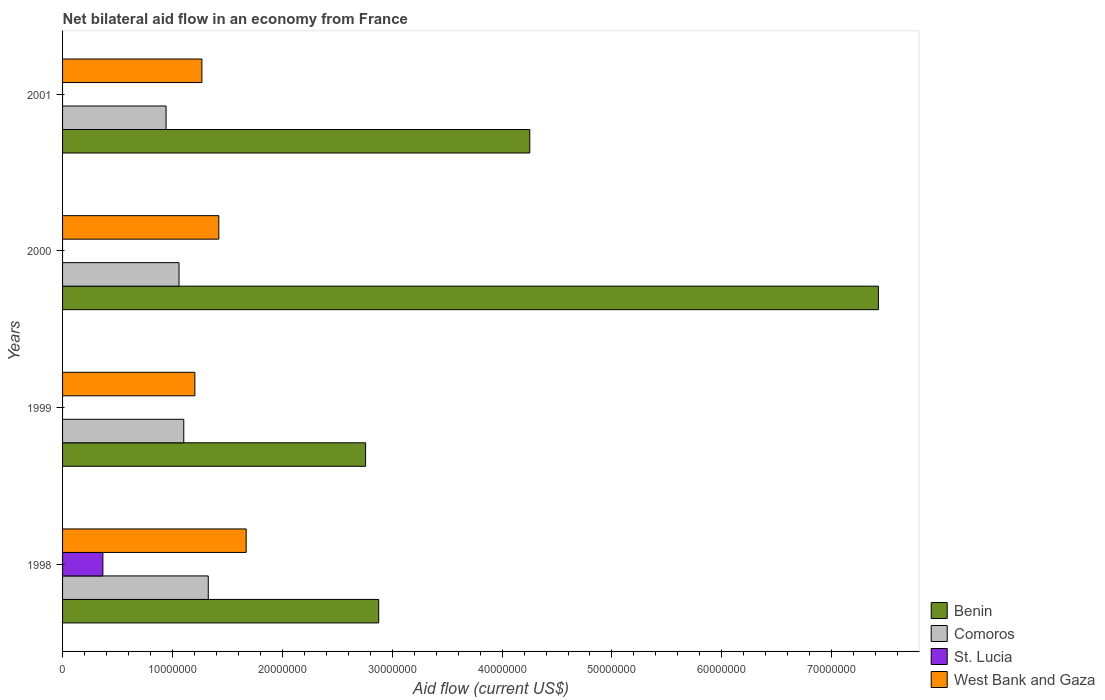How many groups of bars are there?
Your answer should be compact. 4. Are the number of bars on each tick of the Y-axis equal?
Give a very brief answer. No. How many bars are there on the 2nd tick from the top?
Keep it short and to the point. 3. In how many cases, is the number of bars for a given year not equal to the number of legend labels?
Ensure brevity in your answer.  3. What is the net bilateral aid flow in West Bank and Gaza in 2000?
Provide a succinct answer. 1.42e+07. Across all years, what is the maximum net bilateral aid flow in West Bank and Gaza?
Provide a short and direct response. 1.67e+07. Across all years, what is the minimum net bilateral aid flow in Comoros?
Your answer should be very brief. 9.42e+06. In which year was the net bilateral aid flow in Comoros maximum?
Make the answer very short. 1998. What is the total net bilateral aid flow in West Bank and Gaza in the graph?
Give a very brief answer. 5.56e+07. What is the difference between the net bilateral aid flow in West Bank and Gaza in 1999 and that in 2000?
Your response must be concise. -2.18e+06. What is the difference between the net bilateral aid flow in West Bank and Gaza in 1998 and the net bilateral aid flow in St. Lucia in 2001?
Keep it short and to the point. 1.67e+07. What is the average net bilateral aid flow in Comoros per year?
Keep it short and to the point. 1.11e+07. In the year 2000, what is the difference between the net bilateral aid flow in West Bank and Gaza and net bilateral aid flow in Benin?
Ensure brevity in your answer.  -6.00e+07. What is the ratio of the net bilateral aid flow in West Bank and Gaza in 1998 to that in 2000?
Offer a very short reply. 1.18. Is the difference between the net bilateral aid flow in West Bank and Gaza in 2000 and 2001 greater than the difference between the net bilateral aid flow in Benin in 2000 and 2001?
Your response must be concise. No. What is the difference between the highest and the second highest net bilateral aid flow in Comoros?
Ensure brevity in your answer.  2.23e+06. What is the difference between the highest and the lowest net bilateral aid flow in Benin?
Keep it short and to the point. 4.67e+07. In how many years, is the net bilateral aid flow in St. Lucia greater than the average net bilateral aid flow in St. Lucia taken over all years?
Make the answer very short. 1. Is it the case that in every year, the sum of the net bilateral aid flow in Benin and net bilateral aid flow in Comoros is greater than the sum of net bilateral aid flow in St. Lucia and net bilateral aid flow in West Bank and Gaza?
Offer a terse response. No. Is it the case that in every year, the sum of the net bilateral aid flow in West Bank and Gaza and net bilateral aid flow in Benin is greater than the net bilateral aid flow in St. Lucia?
Offer a terse response. Yes. How many bars are there?
Ensure brevity in your answer.  13. Are all the bars in the graph horizontal?
Your answer should be compact. Yes. How many legend labels are there?
Your answer should be very brief. 4. What is the title of the graph?
Provide a succinct answer. Net bilateral aid flow in an economy from France. What is the label or title of the X-axis?
Ensure brevity in your answer.  Aid flow (current US$). What is the Aid flow (current US$) of Benin in 1998?
Offer a terse response. 2.88e+07. What is the Aid flow (current US$) of Comoros in 1998?
Your answer should be compact. 1.33e+07. What is the Aid flow (current US$) in St. Lucia in 1998?
Your response must be concise. 3.67e+06. What is the Aid flow (current US$) of West Bank and Gaza in 1998?
Ensure brevity in your answer.  1.67e+07. What is the Aid flow (current US$) of Benin in 1999?
Give a very brief answer. 2.76e+07. What is the Aid flow (current US$) of Comoros in 1999?
Make the answer very short. 1.10e+07. What is the Aid flow (current US$) in St. Lucia in 1999?
Make the answer very short. 0. What is the Aid flow (current US$) in West Bank and Gaza in 1999?
Keep it short and to the point. 1.20e+07. What is the Aid flow (current US$) in Benin in 2000?
Give a very brief answer. 7.42e+07. What is the Aid flow (current US$) in Comoros in 2000?
Make the answer very short. 1.06e+07. What is the Aid flow (current US$) of West Bank and Gaza in 2000?
Offer a terse response. 1.42e+07. What is the Aid flow (current US$) in Benin in 2001?
Offer a very short reply. 4.25e+07. What is the Aid flow (current US$) of Comoros in 2001?
Offer a very short reply. 9.42e+06. What is the Aid flow (current US$) in St. Lucia in 2001?
Offer a very short reply. 0. What is the Aid flow (current US$) in West Bank and Gaza in 2001?
Give a very brief answer. 1.27e+07. Across all years, what is the maximum Aid flow (current US$) of Benin?
Give a very brief answer. 7.42e+07. Across all years, what is the maximum Aid flow (current US$) in Comoros?
Your answer should be very brief. 1.33e+07. Across all years, what is the maximum Aid flow (current US$) of St. Lucia?
Offer a very short reply. 3.67e+06. Across all years, what is the maximum Aid flow (current US$) in West Bank and Gaza?
Provide a short and direct response. 1.67e+07. Across all years, what is the minimum Aid flow (current US$) in Benin?
Keep it short and to the point. 2.76e+07. Across all years, what is the minimum Aid flow (current US$) in Comoros?
Make the answer very short. 9.42e+06. Across all years, what is the minimum Aid flow (current US$) in West Bank and Gaza?
Provide a short and direct response. 1.20e+07. What is the total Aid flow (current US$) in Benin in the graph?
Your answer should be compact. 1.73e+08. What is the total Aid flow (current US$) in Comoros in the graph?
Keep it short and to the point. 4.43e+07. What is the total Aid flow (current US$) of St. Lucia in the graph?
Provide a short and direct response. 3.67e+06. What is the total Aid flow (current US$) in West Bank and Gaza in the graph?
Provide a succinct answer. 5.56e+07. What is the difference between the Aid flow (current US$) in Benin in 1998 and that in 1999?
Make the answer very short. 1.19e+06. What is the difference between the Aid flow (current US$) of Comoros in 1998 and that in 1999?
Provide a short and direct response. 2.23e+06. What is the difference between the Aid flow (current US$) in West Bank and Gaza in 1998 and that in 1999?
Ensure brevity in your answer.  4.67e+06. What is the difference between the Aid flow (current US$) in Benin in 1998 and that in 2000?
Keep it short and to the point. -4.55e+07. What is the difference between the Aid flow (current US$) in Comoros in 1998 and that in 2000?
Provide a succinct answer. 2.66e+06. What is the difference between the Aid flow (current US$) of West Bank and Gaza in 1998 and that in 2000?
Your answer should be compact. 2.49e+06. What is the difference between the Aid flow (current US$) in Benin in 1998 and that in 2001?
Provide a short and direct response. -1.38e+07. What is the difference between the Aid flow (current US$) in Comoros in 1998 and that in 2001?
Keep it short and to the point. 3.84e+06. What is the difference between the Aid flow (current US$) of West Bank and Gaza in 1998 and that in 2001?
Your response must be concise. 4.03e+06. What is the difference between the Aid flow (current US$) of Benin in 1999 and that in 2000?
Keep it short and to the point. -4.67e+07. What is the difference between the Aid flow (current US$) in Comoros in 1999 and that in 2000?
Offer a very short reply. 4.30e+05. What is the difference between the Aid flow (current US$) of West Bank and Gaza in 1999 and that in 2000?
Your response must be concise. -2.18e+06. What is the difference between the Aid flow (current US$) of Benin in 1999 and that in 2001?
Your response must be concise. -1.49e+07. What is the difference between the Aid flow (current US$) in Comoros in 1999 and that in 2001?
Your response must be concise. 1.61e+06. What is the difference between the Aid flow (current US$) of West Bank and Gaza in 1999 and that in 2001?
Keep it short and to the point. -6.40e+05. What is the difference between the Aid flow (current US$) of Benin in 2000 and that in 2001?
Offer a very short reply. 3.17e+07. What is the difference between the Aid flow (current US$) of Comoros in 2000 and that in 2001?
Your response must be concise. 1.18e+06. What is the difference between the Aid flow (current US$) in West Bank and Gaza in 2000 and that in 2001?
Provide a succinct answer. 1.54e+06. What is the difference between the Aid flow (current US$) of Benin in 1998 and the Aid flow (current US$) of Comoros in 1999?
Your response must be concise. 1.77e+07. What is the difference between the Aid flow (current US$) in Benin in 1998 and the Aid flow (current US$) in West Bank and Gaza in 1999?
Offer a very short reply. 1.67e+07. What is the difference between the Aid flow (current US$) in Comoros in 1998 and the Aid flow (current US$) in West Bank and Gaza in 1999?
Provide a short and direct response. 1.22e+06. What is the difference between the Aid flow (current US$) of St. Lucia in 1998 and the Aid flow (current US$) of West Bank and Gaza in 1999?
Give a very brief answer. -8.37e+06. What is the difference between the Aid flow (current US$) in Benin in 1998 and the Aid flow (current US$) in Comoros in 2000?
Provide a short and direct response. 1.82e+07. What is the difference between the Aid flow (current US$) of Benin in 1998 and the Aid flow (current US$) of West Bank and Gaza in 2000?
Offer a terse response. 1.46e+07. What is the difference between the Aid flow (current US$) in Comoros in 1998 and the Aid flow (current US$) in West Bank and Gaza in 2000?
Provide a succinct answer. -9.60e+05. What is the difference between the Aid flow (current US$) in St. Lucia in 1998 and the Aid flow (current US$) in West Bank and Gaza in 2000?
Keep it short and to the point. -1.06e+07. What is the difference between the Aid flow (current US$) in Benin in 1998 and the Aid flow (current US$) in Comoros in 2001?
Provide a short and direct response. 1.94e+07. What is the difference between the Aid flow (current US$) of Benin in 1998 and the Aid flow (current US$) of West Bank and Gaza in 2001?
Provide a succinct answer. 1.61e+07. What is the difference between the Aid flow (current US$) in Comoros in 1998 and the Aid flow (current US$) in West Bank and Gaza in 2001?
Ensure brevity in your answer.  5.80e+05. What is the difference between the Aid flow (current US$) in St. Lucia in 1998 and the Aid flow (current US$) in West Bank and Gaza in 2001?
Your answer should be very brief. -9.01e+06. What is the difference between the Aid flow (current US$) in Benin in 1999 and the Aid flow (current US$) in Comoros in 2000?
Give a very brief answer. 1.70e+07. What is the difference between the Aid flow (current US$) in Benin in 1999 and the Aid flow (current US$) in West Bank and Gaza in 2000?
Your response must be concise. 1.34e+07. What is the difference between the Aid flow (current US$) in Comoros in 1999 and the Aid flow (current US$) in West Bank and Gaza in 2000?
Your answer should be compact. -3.19e+06. What is the difference between the Aid flow (current US$) of Benin in 1999 and the Aid flow (current US$) of Comoros in 2001?
Offer a terse response. 1.82e+07. What is the difference between the Aid flow (current US$) in Benin in 1999 and the Aid flow (current US$) in West Bank and Gaza in 2001?
Your answer should be very brief. 1.49e+07. What is the difference between the Aid flow (current US$) of Comoros in 1999 and the Aid flow (current US$) of West Bank and Gaza in 2001?
Make the answer very short. -1.65e+06. What is the difference between the Aid flow (current US$) in Benin in 2000 and the Aid flow (current US$) in Comoros in 2001?
Ensure brevity in your answer.  6.48e+07. What is the difference between the Aid flow (current US$) in Benin in 2000 and the Aid flow (current US$) in West Bank and Gaza in 2001?
Your response must be concise. 6.16e+07. What is the difference between the Aid flow (current US$) of Comoros in 2000 and the Aid flow (current US$) of West Bank and Gaza in 2001?
Ensure brevity in your answer.  -2.08e+06. What is the average Aid flow (current US$) of Benin per year?
Make the answer very short. 4.33e+07. What is the average Aid flow (current US$) of Comoros per year?
Make the answer very short. 1.11e+07. What is the average Aid flow (current US$) in St. Lucia per year?
Keep it short and to the point. 9.18e+05. What is the average Aid flow (current US$) of West Bank and Gaza per year?
Keep it short and to the point. 1.39e+07. In the year 1998, what is the difference between the Aid flow (current US$) in Benin and Aid flow (current US$) in Comoros?
Your answer should be compact. 1.55e+07. In the year 1998, what is the difference between the Aid flow (current US$) of Benin and Aid flow (current US$) of St. Lucia?
Your answer should be compact. 2.51e+07. In the year 1998, what is the difference between the Aid flow (current US$) of Benin and Aid flow (current US$) of West Bank and Gaza?
Make the answer very short. 1.21e+07. In the year 1998, what is the difference between the Aid flow (current US$) in Comoros and Aid flow (current US$) in St. Lucia?
Make the answer very short. 9.59e+06. In the year 1998, what is the difference between the Aid flow (current US$) in Comoros and Aid flow (current US$) in West Bank and Gaza?
Provide a short and direct response. -3.45e+06. In the year 1998, what is the difference between the Aid flow (current US$) of St. Lucia and Aid flow (current US$) of West Bank and Gaza?
Offer a terse response. -1.30e+07. In the year 1999, what is the difference between the Aid flow (current US$) of Benin and Aid flow (current US$) of Comoros?
Make the answer very short. 1.66e+07. In the year 1999, what is the difference between the Aid flow (current US$) in Benin and Aid flow (current US$) in West Bank and Gaza?
Your answer should be compact. 1.55e+07. In the year 1999, what is the difference between the Aid flow (current US$) in Comoros and Aid flow (current US$) in West Bank and Gaza?
Provide a short and direct response. -1.01e+06. In the year 2000, what is the difference between the Aid flow (current US$) in Benin and Aid flow (current US$) in Comoros?
Your answer should be compact. 6.36e+07. In the year 2000, what is the difference between the Aid flow (current US$) in Benin and Aid flow (current US$) in West Bank and Gaza?
Provide a short and direct response. 6.00e+07. In the year 2000, what is the difference between the Aid flow (current US$) of Comoros and Aid flow (current US$) of West Bank and Gaza?
Your answer should be compact. -3.62e+06. In the year 2001, what is the difference between the Aid flow (current US$) of Benin and Aid flow (current US$) of Comoros?
Provide a succinct answer. 3.31e+07. In the year 2001, what is the difference between the Aid flow (current US$) in Benin and Aid flow (current US$) in West Bank and Gaza?
Your answer should be compact. 2.98e+07. In the year 2001, what is the difference between the Aid flow (current US$) in Comoros and Aid flow (current US$) in West Bank and Gaza?
Make the answer very short. -3.26e+06. What is the ratio of the Aid flow (current US$) of Benin in 1998 to that in 1999?
Give a very brief answer. 1.04. What is the ratio of the Aid flow (current US$) in Comoros in 1998 to that in 1999?
Offer a terse response. 1.2. What is the ratio of the Aid flow (current US$) in West Bank and Gaza in 1998 to that in 1999?
Your answer should be very brief. 1.39. What is the ratio of the Aid flow (current US$) in Benin in 1998 to that in 2000?
Your answer should be very brief. 0.39. What is the ratio of the Aid flow (current US$) of Comoros in 1998 to that in 2000?
Provide a succinct answer. 1.25. What is the ratio of the Aid flow (current US$) in West Bank and Gaza in 1998 to that in 2000?
Offer a very short reply. 1.18. What is the ratio of the Aid flow (current US$) in Benin in 1998 to that in 2001?
Offer a very short reply. 0.68. What is the ratio of the Aid flow (current US$) in Comoros in 1998 to that in 2001?
Offer a terse response. 1.41. What is the ratio of the Aid flow (current US$) of West Bank and Gaza in 1998 to that in 2001?
Give a very brief answer. 1.32. What is the ratio of the Aid flow (current US$) of Benin in 1999 to that in 2000?
Your answer should be very brief. 0.37. What is the ratio of the Aid flow (current US$) in Comoros in 1999 to that in 2000?
Your answer should be compact. 1.04. What is the ratio of the Aid flow (current US$) of West Bank and Gaza in 1999 to that in 2000?
Keep it short and to the point. 0.85. What is the ratio of the Aid flow (current US$) of Benin in 1999 to that in 2001?
Your answer should be very brief. 0.65. What is the ratio of the Aid flow (current US$) in Comoros in 1999 to that in 2001?
Give a very brief answer. 1.17. What is the ratio of the Aid flow (current US$) of West Bank and Gaza in 1999 to that in 2001?
Ensure brevity in your answer.  0.95. What is the ratio of the Aid flow (current US$) of Benin in 2000 to that in 2001?
Your answer should be very brief. 1.75. What is the ratio of the Aid flow (current US$) of Comoros in 2000 to that in 2001?
Provide a succinct answer. 1.13. What is the ratio of the Aid flow (current US$) in West Bank and Gaza in 2000 to that in 2001?
Offer a terse response. 1.12. What is the difference between the highest and the second highest Aid flow (current US$) in Benin?
Offer a very short reply. 3.17e+07. What is the difference between the highest and the second highest Aid flow (current US$) in Comoros?
Give a very brief answer. 2.23e+06. What is the difference between the highest and the second highest Aid flow (current US$) of West Bank and Gaza?
Your answer should be compact. 2.49e+06. What is the difference between the highest and the lowest Aid flow (current US$) of Benin?
Provide a succinct answer. 4.67e+07. What is the difference between the highest and the lowest Aid flow (current US$) of Comoros?
Provide a succinct answer. 3.84e+06. What is the difference between the highest and the lowest Aid flow (current US$) of St. Lucia?
Your response must be concise. 3.67e+06. What is the difference between the highest and the lowest Aid flow (current US$) of West Bank and Gaza?
Your answer should be very brief. 4.67e+06. 